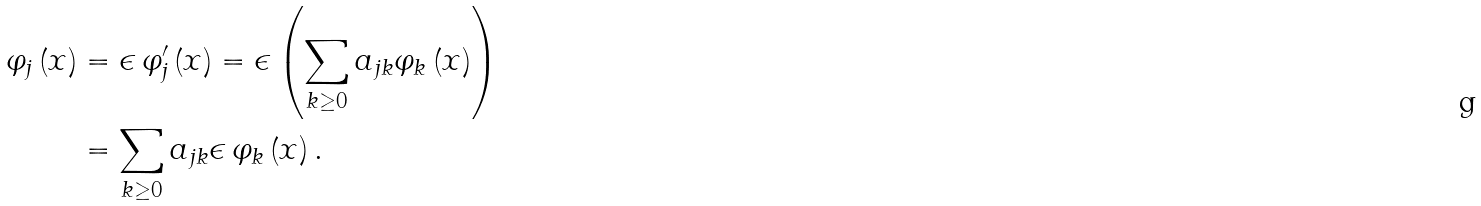<formula> <loc_0><loc_0><loc_500><loc_500>\varphi _ { j } \left ( x \right ) & = \epsilon \, \varphi _ { j } ^ { \prime } \left ( x \right ) = \epsilon \left ( \sum _ { k \geq 0 } a _ { j k } \varphi _ { k } \left ( x \right ) \right ) \\ & = \sum _ { k \geq 0 } a _ { j k } \epsilon \, \varphi _ { k } \left ( x \right ) .</formula> 